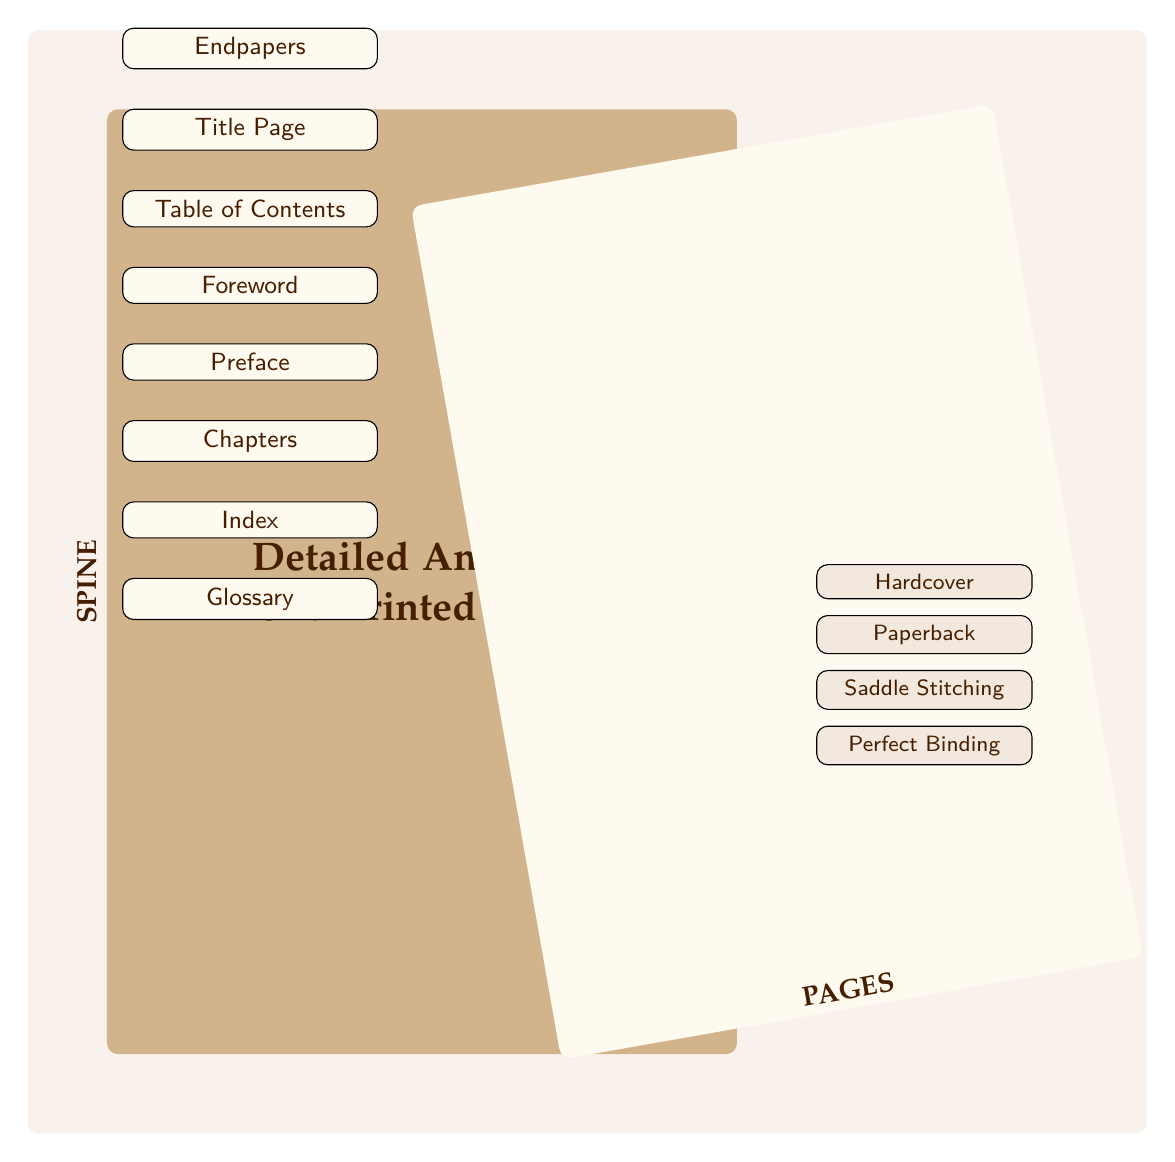What is the title of the diagram? The title is clearly written at the center of the cover, stating what the diagram represents.
Answer: Detailed Anatomy of a Printed Book How many book parts are listed in the diagram? By counting the different parts listed from Endpapers to Glossary, we see there are seven specific parts mentioned.
Answer: 7 What is labeled at the bottom of the pages section? The term at the bottom of the pages section is marked to indicate what this section represents.
Answer: PAGES Which binding type is located directly below Paperback? The binding types are listed vertically, and by looking at the list, we find what comes immediately after Paperback.
Answer: Saddle Stitching What type of binding is labeled 'Hardcover'? Observing the bindings listed in the diagram, we identify the one labeled as Hardcover as the first binding type.
Answer: Hardcover Which part of the book comes right after the Title Page? To answer this, we look at the sequential order of book parts presented in the diagram, finding what follows the Title Page.
Answer: Table of Contents If you start from the Endpapers, which part comes fourth in the sequence? Following the order from Endpapers, we count down to determine what is the fourth part in the list of book parts.
Answer: Preface What color represents the cover in this diagram? This can be identified by looking at the fill color used for the cover section in the diagram.
Answer: RGB(210,180,140) What is the prominent feature indicated by the node on the left side of the 'PAGES'? By examining the node on the left side of the 'PAGES' section, we can identify what this node represents in relation to the book.
Answer: SPINE 